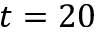Convert formula to latex. <formula><loc_0><loc_0><loc_500><loc_500>t = 2 0</formula> 